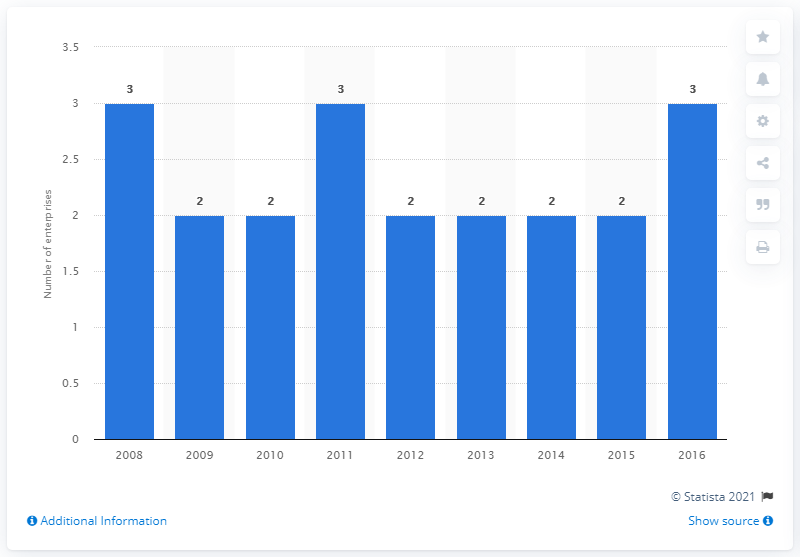Give some essential details in this illustration. In 2014, there were two companies manufacturing cement in Norway. 